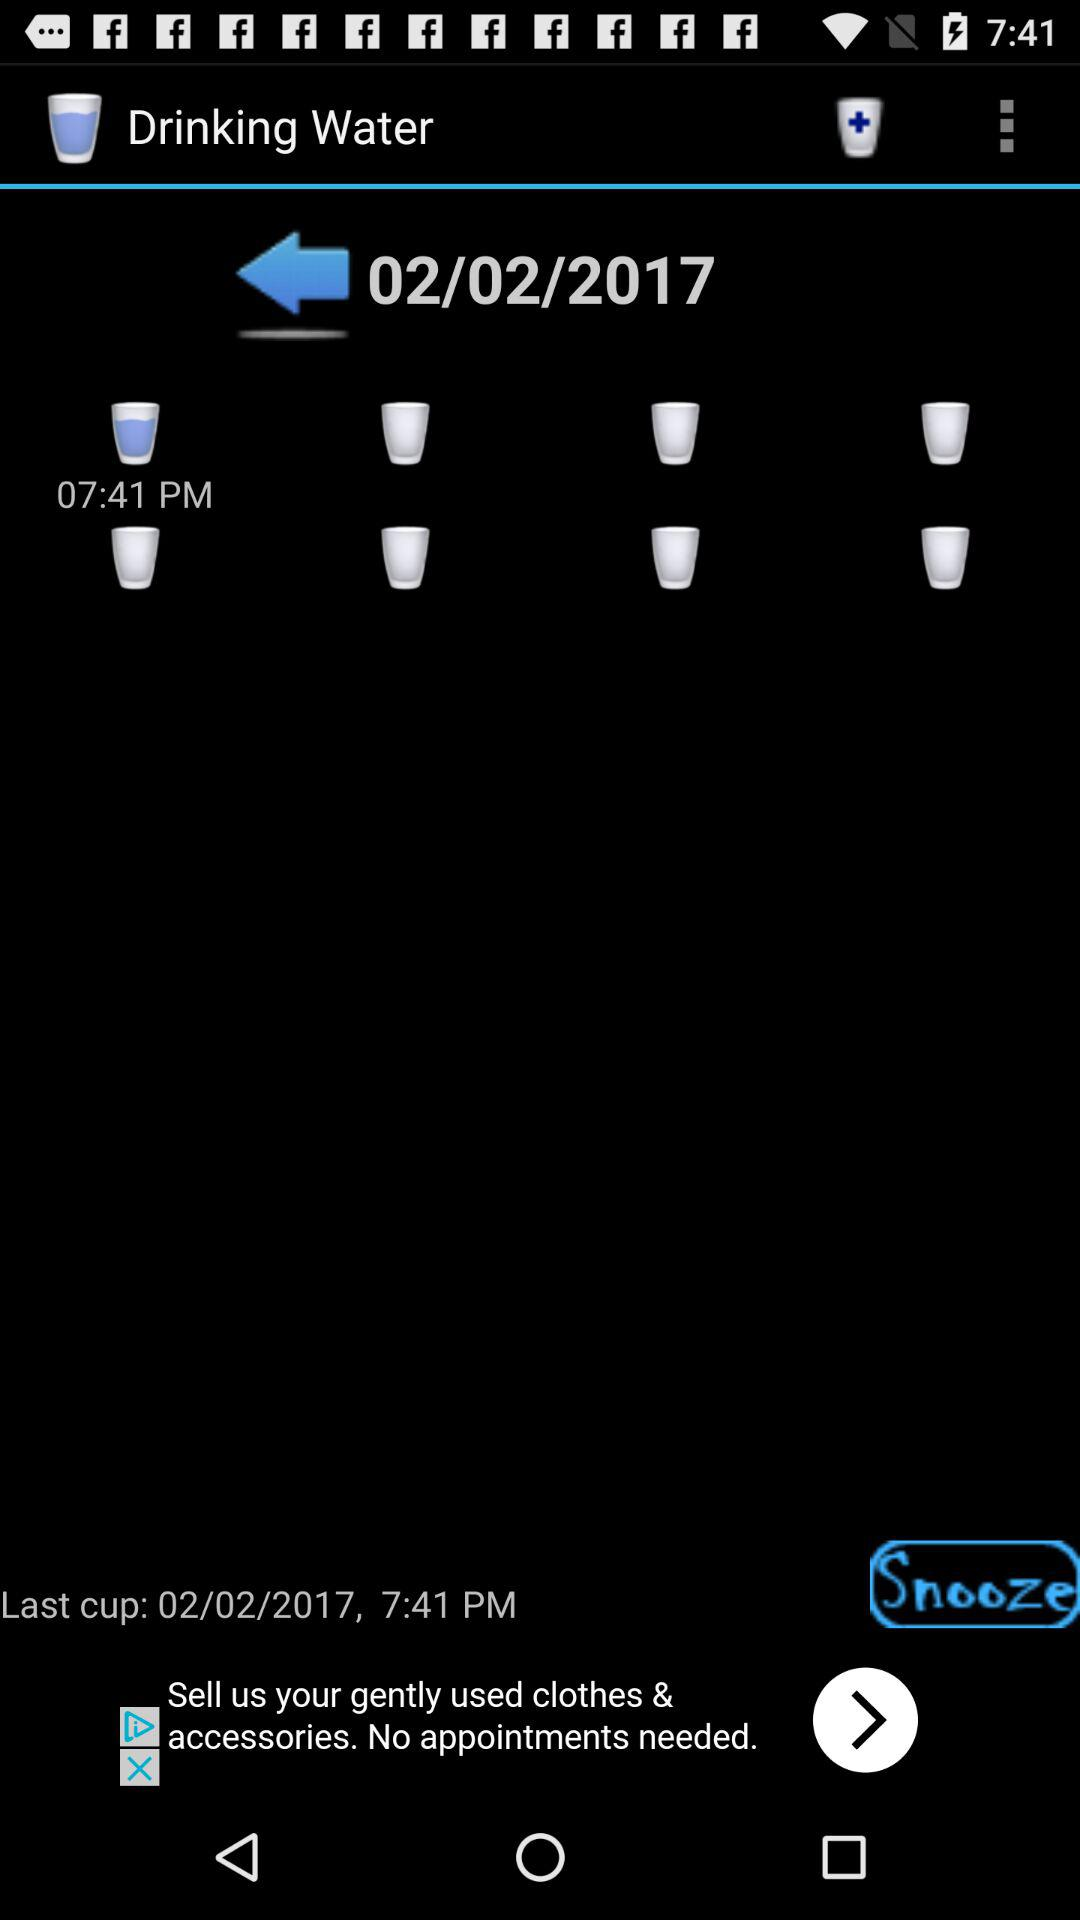What is the given timing? The given name is 07:41 PM. 